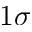Convert formula to latex. <formula><loc_0><loc_0><loc_500><loc_500>1 \sigma</formula> 